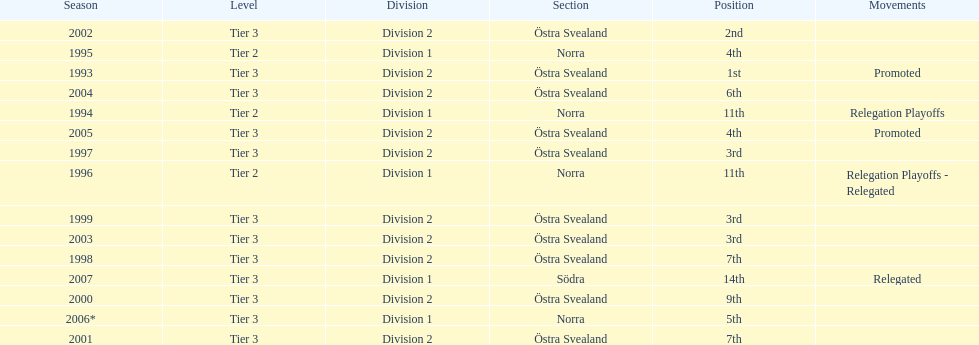What are the number of times norra was listed as the section? 4. 